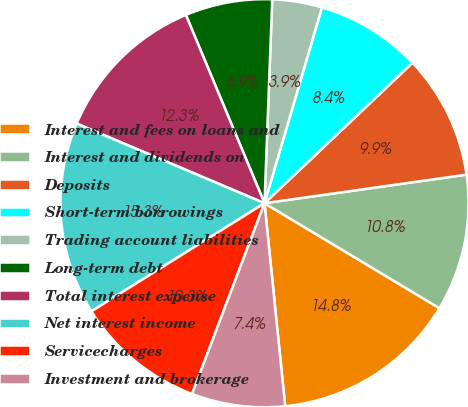Convert chart to OTSL. <chart><loc_0><loc_0><loc_500><loc_500><pie_chart><fcel>Interest and fees on loans and<fcel>Interest and dividends on<fcel>Deposits<fcel>Short-term borrowings<fcel>Trading account liabilities<fcel>Long-term debt<fcel>Total interest expense<fcel>Net interest income<fcel>Servicecharges<fcel>Investment and brokerage<nl><fcel>14.78%<fcel>10.84%<fcel>9.85%<fcel>8.37%<fcel>3.94%<fcel>6.9%<fcel>12.32%<fcel>15.27%<fcel>10.34%<fcel>7.39%<nl></chart> 